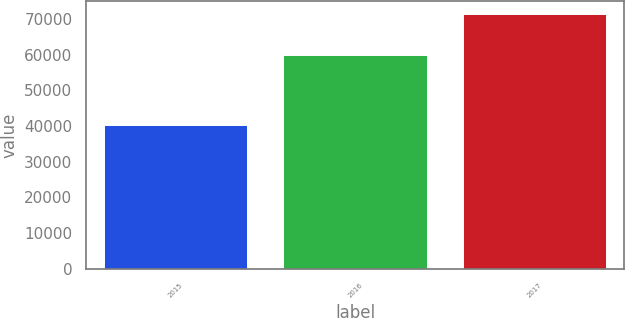Convert chart to OTSL. <chart><loc_0><loc_0><loc_500><loc_500><bar_chart><fcel>2015<fcel>2016<fcel>2017<nl><fcel>40182<fcel>60009<fcel>71359<nl></chart> 